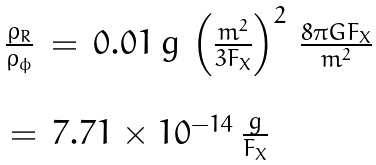<formula> <loc_0><loc_0><loc_500><loc_500>\begin{array} { l } { \frac { \rho _ { R } } { \rho _ { \phi } } \, = \, 0 . 0 1 \, g \, \left ( \frac { m ^ { 2 } } { 3 F _ { X } } \right ) ^ { 2 } \, \frac { 8 \pi G F _ { X } } { m ^ { 2 } } } \\ \\ { \, = \, 7 . 7 1 \times 1 0 ^ { - 1 4 } \, \frac { g } { F _ { X } } } \end{array}</formula> 